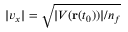<formula> <loc_0><loc_0><loc_500><loc_500>| v _ { x } | = \sqrt { | V ( r ( t _ { 0 } ) ) | / n _ { f } }</formula> 